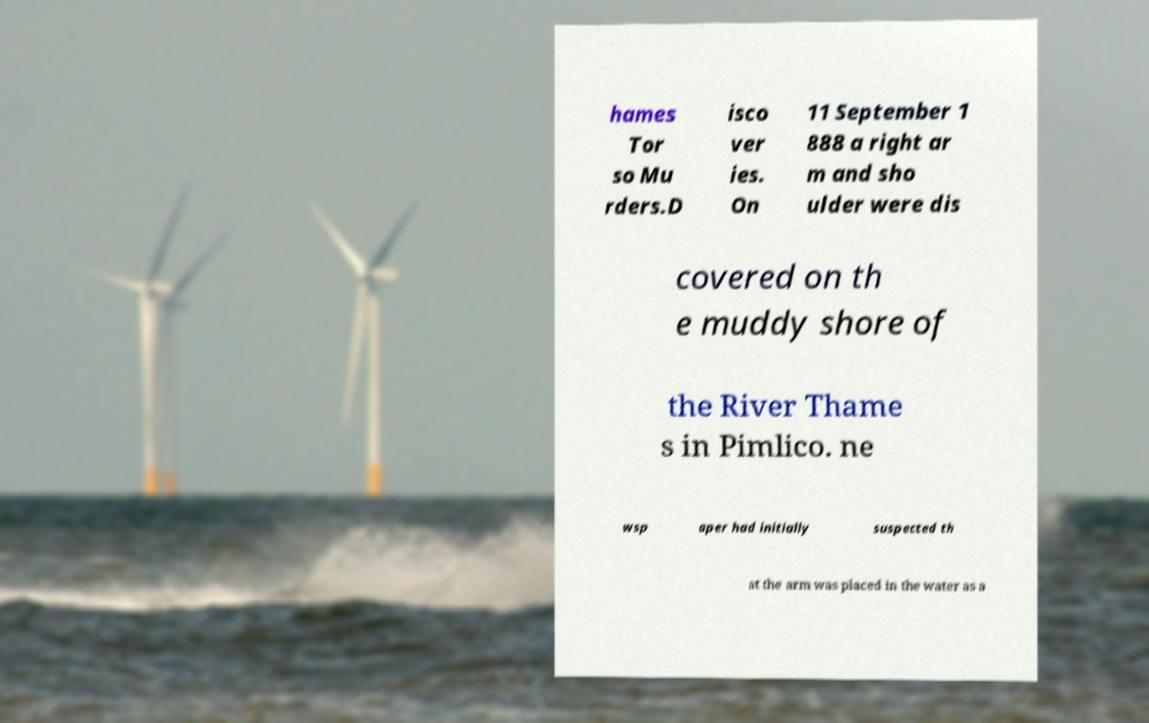There's text embedded in this image that I need extracted. Can you transcribe it verbatim? hames Tor so Mu rders.D isco ver ies. On 11 September 1 888 a right ar m and sho ulder were dis covered on th e muddy shore of the River Thame s in Pimlico. ne wsp aper had initially suspected th at the arm was placed in the water as a 